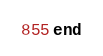Convert code to text. <code><loc_0><loc_0><loc_500><loc_500><_Ruby_>end
</code> 